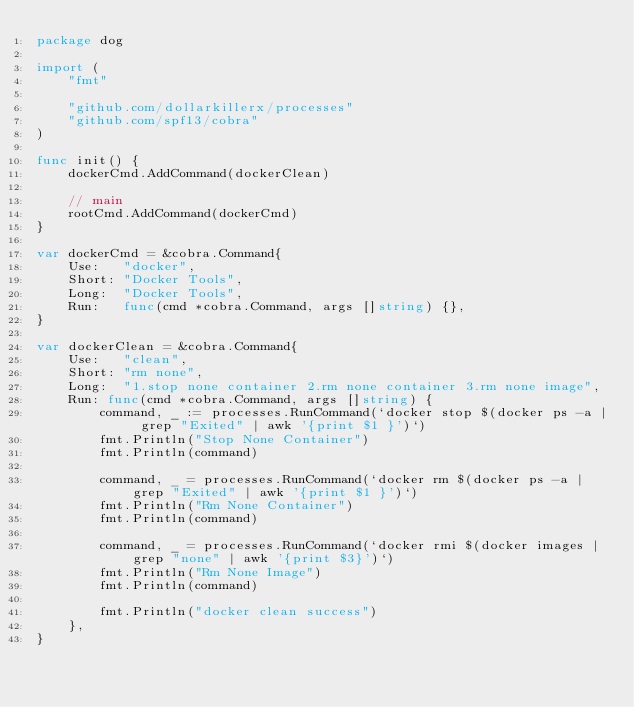Convert code to text. <code><loc_0><loc_0><loc_500><loc_500><_Go_>package dog

import (
	"fmt"

	"github.com/dollarkillerx/processes"
	"github.com/spf13/cobra"
)

func init() {
	dockerCmd.AddCommand(dockerClean)

	// main
	rootCmd.AddCommand(dockerCmd)
}

var dockerCmd = &cobra.Command{
	Use:   "docker",
	Short: "Docker Tools",
	Long:  "Docker Tools",
	Run:   func(cmd *cobra.Command, args []string) {},
}

var dockerClean = &cobra.Command{
	Use:   "clean",
	Short: "rm none",
	Long:  "1.stop none container 2.rm none container 3.rm none image",
	Run: func(cmd *cobra.Command, args []string) {
		command, _ := processes.RunCommand(`docker stop $(docker ps -a | grep "Exited" | awk '{print $1 }')`)
		fmt.Println("Stop None Container")
		fmt.Println(command)

		command, _ = processes.RunCommand(`docker rm $(docker ps -a | grep "Exited" | awk '{print $1 }')`)
		fmt.Println("Rm None Container")
		fmt.Println(command)

		command, _ = processes.RunCommand(`docker rmi $(docker images | grep "none" | awk '{print $3}')`)
		fmt.Println("Rm None Image")
		fmt.Println(command)

		fmt.Println("docker clean success")
	},
}
</code> 